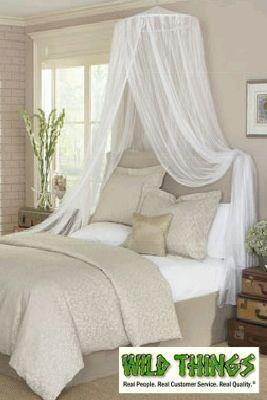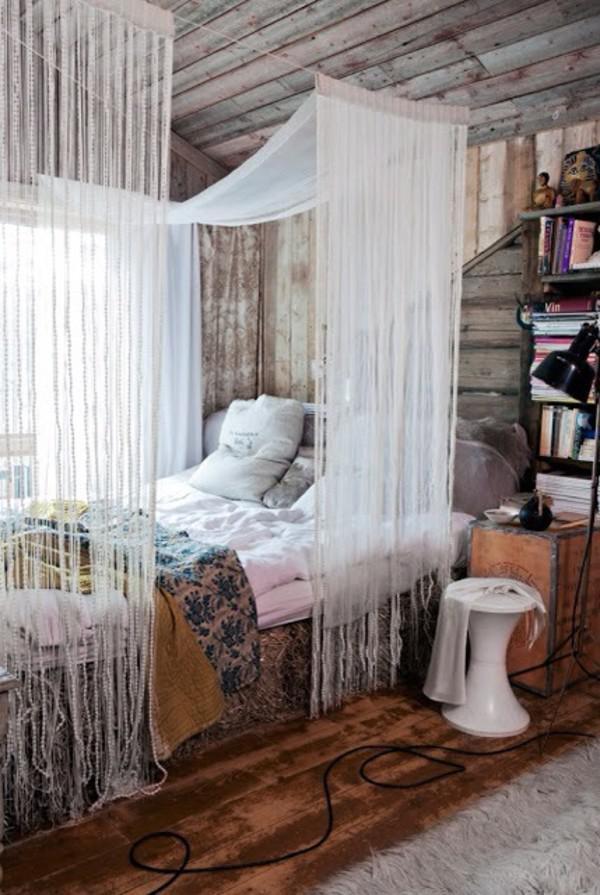The first image is the image on the left, the second image is the image on the right. For the images shown, is this caption "The bed on the right is draped by a canopy that descends from a centrally suspended cone shape." true? Answer yes or no. No. 